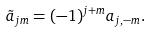<formula> <loc_0><loc_0><loc_500><loc_500>\tilde { a } _ { j m } = ( - 1 ) ^ { j + m } a _ { j , - m } .</formula> 